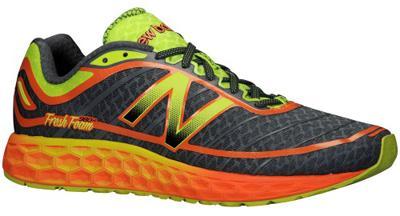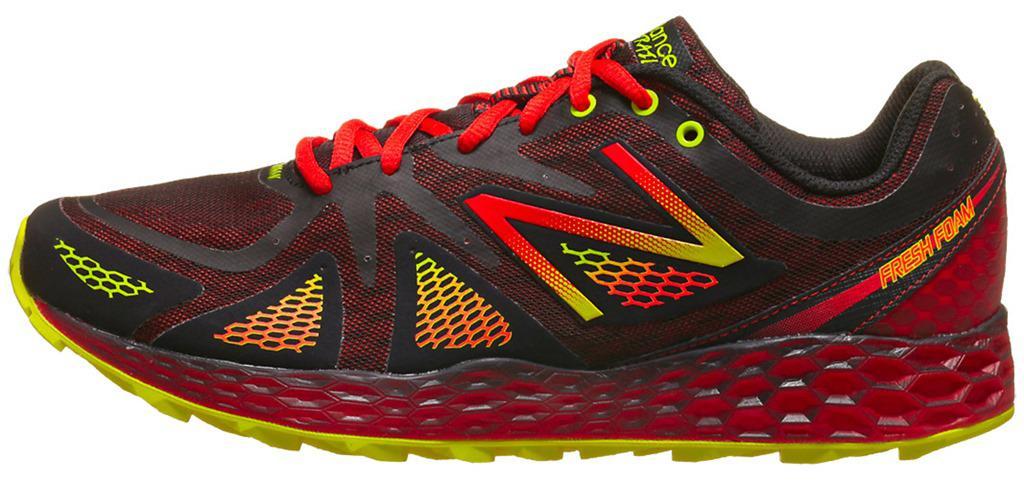The first image is the image on the left, the second image is the image on the right. Analyze the images presented: Is the assertion "Each image contains a single sneaker, and the sneakers in the left and right images face different [left vs right] directions." valid? Answer yes or no. Yes. The first image is the image on the left, the second image is the image on the right. Assess this claim about the two images: "A single shoe sits on a white surface in each of the images.". Correct or not? Answer yes or no. Yes. 